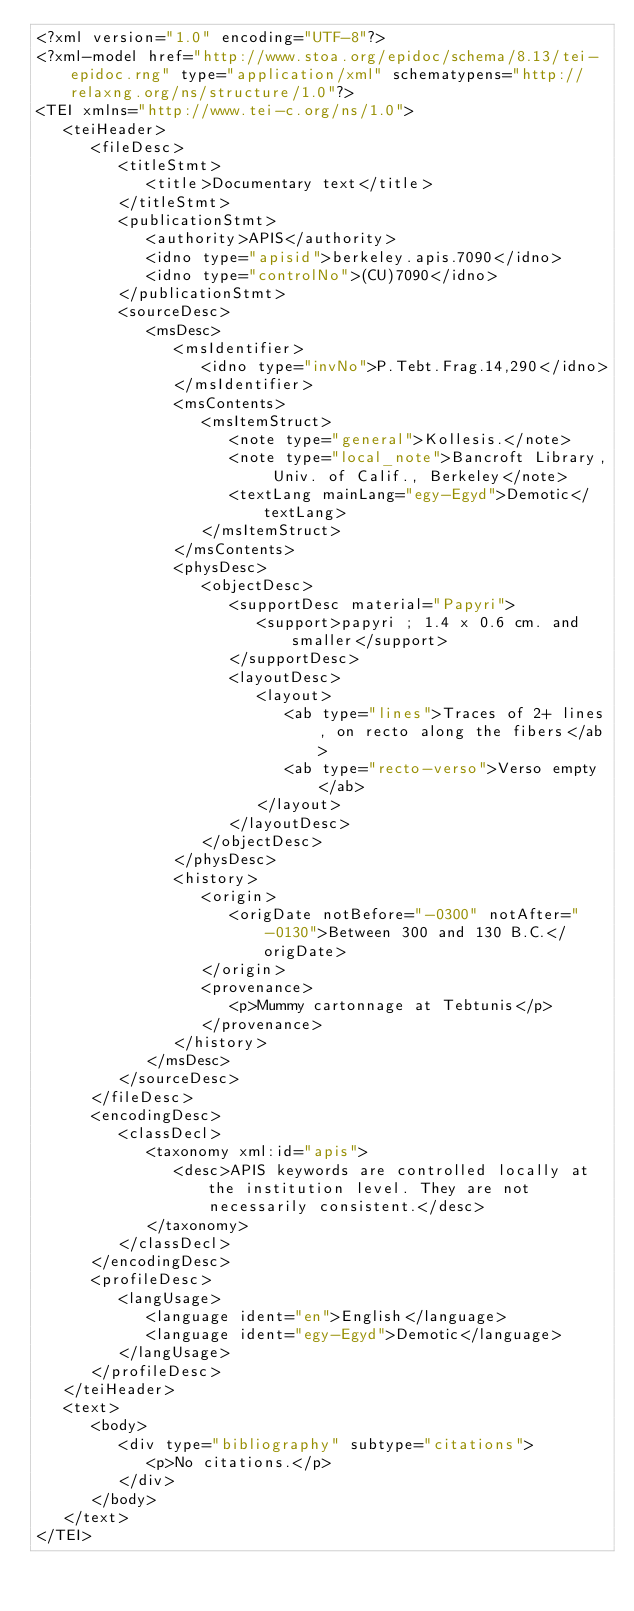Convert code to text. <code><loc_0><loc_0><loc_500><loc_500><_XML_><?xml version="1.0" encoding="UTF-8"?>
<?xml-model href="http://www.stoa.org/epidoc/schema/8.13/tei-epidoc.rng" type="application/xml" schematypens="http://relaxng.org/ns/structure/1.0"?>
<TEI xmlns="http://www.tei-c.org/ns/1.0">
   <teiHeader>
      <fileDesc>
         <titleStmt>
            <title>Documentary text</title>
         </titleStmt>
         <publicationStmt>
            <authority>APIS</authority>
            <idno type="apisid">berkeley.apis.7090</idno>
            <idno type="controlNo">(CU)7090</idno>
         </publicationStmt>
         <sourceDesc>
            <msDesc>
               <msIdentifier>
                  <idno type="invNo">P.Tebt.Frag.14,290</idno>
               </msIdentifier>
               <msContents>
                  <msItemStruct>
                     <note type="general">Kollesis.</note>
                     <note type="local_note">Bancroft Library, Univ. of Calif., Berkeley</note>
                     <textLang mainLang="egy-Egyd">Demotic</textLang>
                  </msItemStruct>
               </msContents>
               <physDesc>
                  <objectDesc>
                     <supportDesc material="Papyri">
                        <support>papyri ; 1.4 x 0.6 cm. and smaller</support>
                     </supportDesc>
                     <layoutDesc>
                        <layout>
                           <ab type="lines">Traces of 2+ lines, on recto along the fibers</ab>
                           <ab type="recto-verso">Verso empty</ab>
                        </layout>
                     </layoutDesc>
                  </objectDesc>
               </physDesc>
               <history>
                  <origin>
                     <origDate notBefore="-0300" notAfter="-0130">Between 300 and 130 B.C.</origDate>
                  </origin>
                  <provenance>
                     <p>Mummy cartonnage at Tebtunis</p>
                  </provenance>
               </history>
            </msDesc>
         </sourceDesc>
      </fileDesc>
      <encodingDesc>
         <classDecl>
            <taxonomy xml:id="apis">
               <desc>APIS keywords are controlled locally at the institution level. They are not necessarily consistent.</desc>
            </taxonomy>
         </classDecl>
      </encodingDesc>
      <profileDesc>
         <langUsage>
            <language ident="en">English</language>
            <language ident="egy-Egyd">Demotic</language>
         </langUsage>
      </profileDesc>
   </teiHeader>
   <text>
      <body>
         <div type="bibliography" subtype="citations">
            <p>No citations.</p>
         </div>
      </body>
   </text>
</TEI></code> 